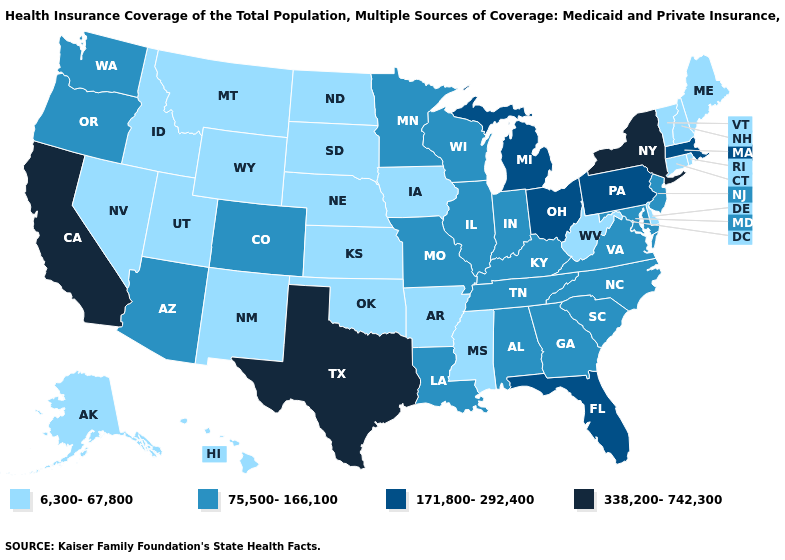Which states have the lowest value in the Northeast?
Short answer required. Connecticut, Maine, New Hampshire, Rhode Island, Vermont. Does North Carolina have the lowest value in the South?
Keep it brief. No. Which states have the lowest value in the USA?
Answer briefly. Alaska, Arkansas, Connecticut, Delaware, Hawaii, Idaho, Iowa, Kansas, Maine, Mississippi, Montana, Nebraska, Nevada, New Hampshire, New Mexico, North Dakota, Oklahoma, Rhode Island, South Dakota, Utah, Vermont, West Virginia, Wyoming. Name the states that have a value in the range 171,800-292,400?
Quick response, please. Florida, Massachusetts, Michigan, Ohio, Pennsylvania. Name the states that have a value in the range 75,500-166,100?
Give a very brief answer. Alabama, Arizona, Colorado, Georgia, Illinois, Indiana, Kentucky, Louisiana, Maryland, Minnesota, Missouri, New Jersey, North Carolina, Oregon, South Carolina, Tennessee, Virginia, Washington, Wisconsin. What is the value of Idaho?
Concise answer only. 6,300-67,800. What is the value of Missouri?
Answer briefly. 75,500-166,100. What is the value of Maine?
Write a very short answer. 6,300-67,800. Name the states that have a value in the range 6,300-67,800?
Quick response, please. Alaska, Arkansas, Connecticut, Delaware, Hawaii, Idaho, Iowa, Kansas, Maine, Mississippi, Montana, Nebraska, Nevada, New Hampshire, New Mexico, North Dakota, Oklahoma, Rhode Island, South Dakota, Utah, Vermont, West Virginia, Wyoming. Does New York have the same value as Texas?
Give a very brief answer. Yes. Name the states that have a value in the range 338,200-742,300?
Quick response, please. California, New York, Texas. Which states hav the highest value in the MidWest?
Give a very brief answer. Michigan, Ohio. What is the value of New Jersey?
Short answer required. 75,500-166,100. What is the value of South Dakota?
Answer briefly. 6,300-67,800. What is the value of Indiana?
Answer briefly. 75,500-166,100. 